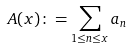<formula> <loc_0><loc_0><loc_500><loc_500>A ( x ) \colon = \sum _ { 1 \leq n \leq x } a _ { n }</formula> 